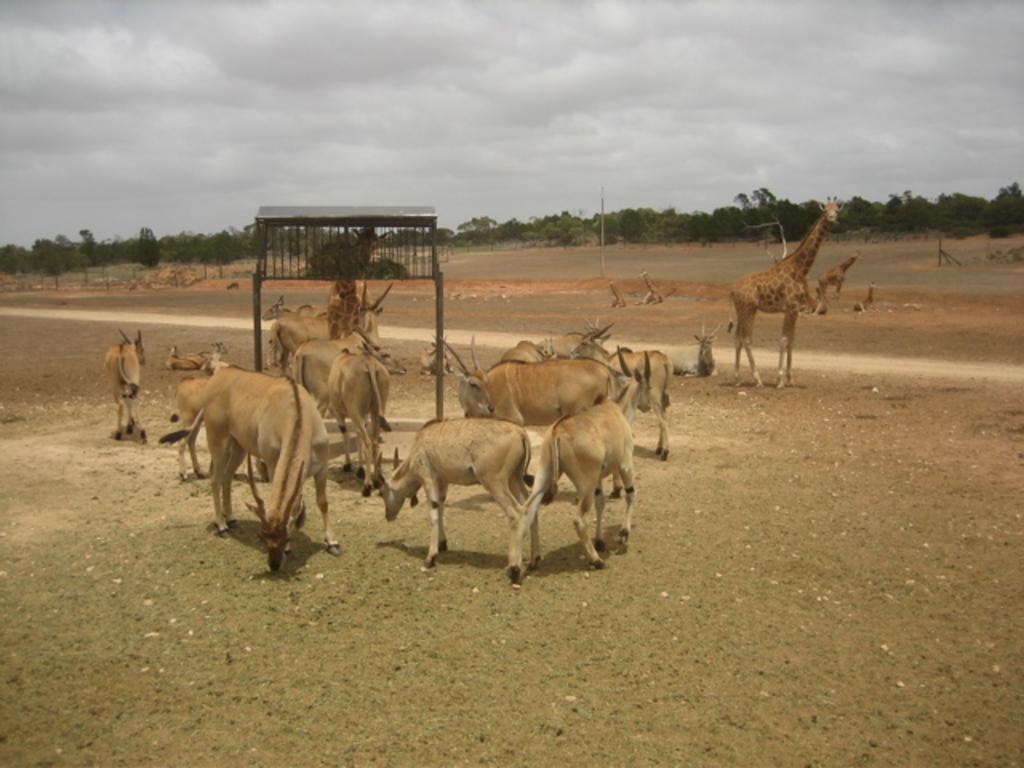In one or two sentences, can you explain what this image depicts? In this picture in the center there are animals standing and in the background there are trees. In the center there is a stand and the sky is cloudy. 